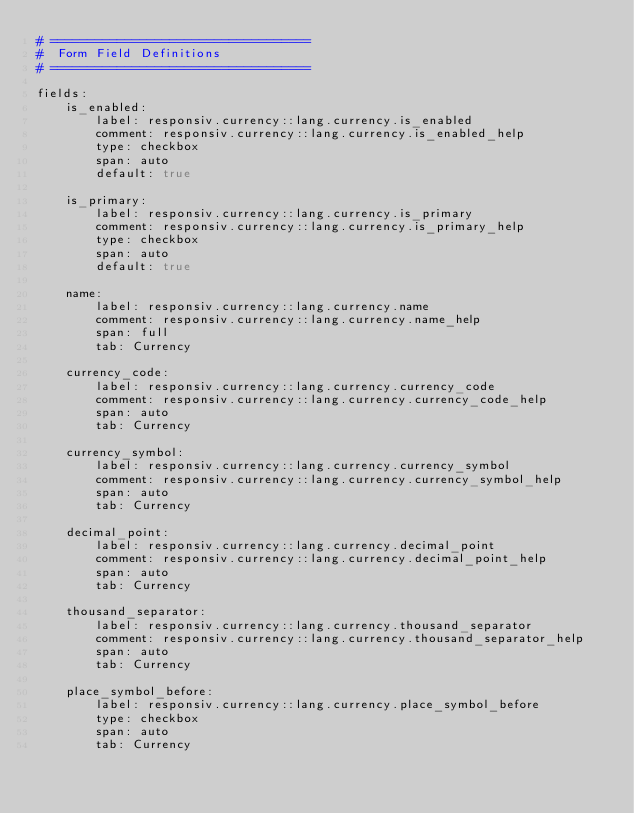<code> <loc_0><loc_0><loc_500><loc_500><_YAML_># ===================================
#  Form Field Definitions
# ===================================

fields:
    is_enabled:
        label: responsiv.currency::lang.currency.is_enabled
        comment: responsiv.currency::lang.currency.is_enabled_help
        type: checkbox
        span: auto
        default: true

    is_primary:
        label: responsiv.currency::lang.currency.is_primary
        comment: responsiv.currency::lang.currency.is_primary_help
        type: checkbox
        span: auto
        default: true

    name:
        label: responsiv.currency::lang.currency.name
        comment: responsiv.currency::lang.currency.name_help
        span: full
        tab: Currency
        
    currency_code:
        label: responsiv.currency::lang.currency.currency_code
        comment: responsiv.currency::lang.currency.currency_code_help
        span: auto
        tab: Currency

    currency_symbol:
        label: responsiv.currency::lang.currency.currency_symbol
        comment: responsiv.currency::lang.currency.currency_symbol_help
        span: auto
        tab: Currency

    decimal_point:
        label: responsiv.currency::lang.currency.decimal_point
        comment: responsiv.currency::lang.currency.decimal_point_help
        span: auto
        tab: Currency

    thousand_separator:
        label: responsiv.currency::lang.currency.thousand_separator
        comment: responsiv.currency::lang.currency.thousand_separator_help
        span: auto
        tab: Currency

    place_symbol_before:
        label: responsiv.currency::lang.currency.place_symbol_before
        type: checkbox
        span: auto
        tab: Currency
</code> 